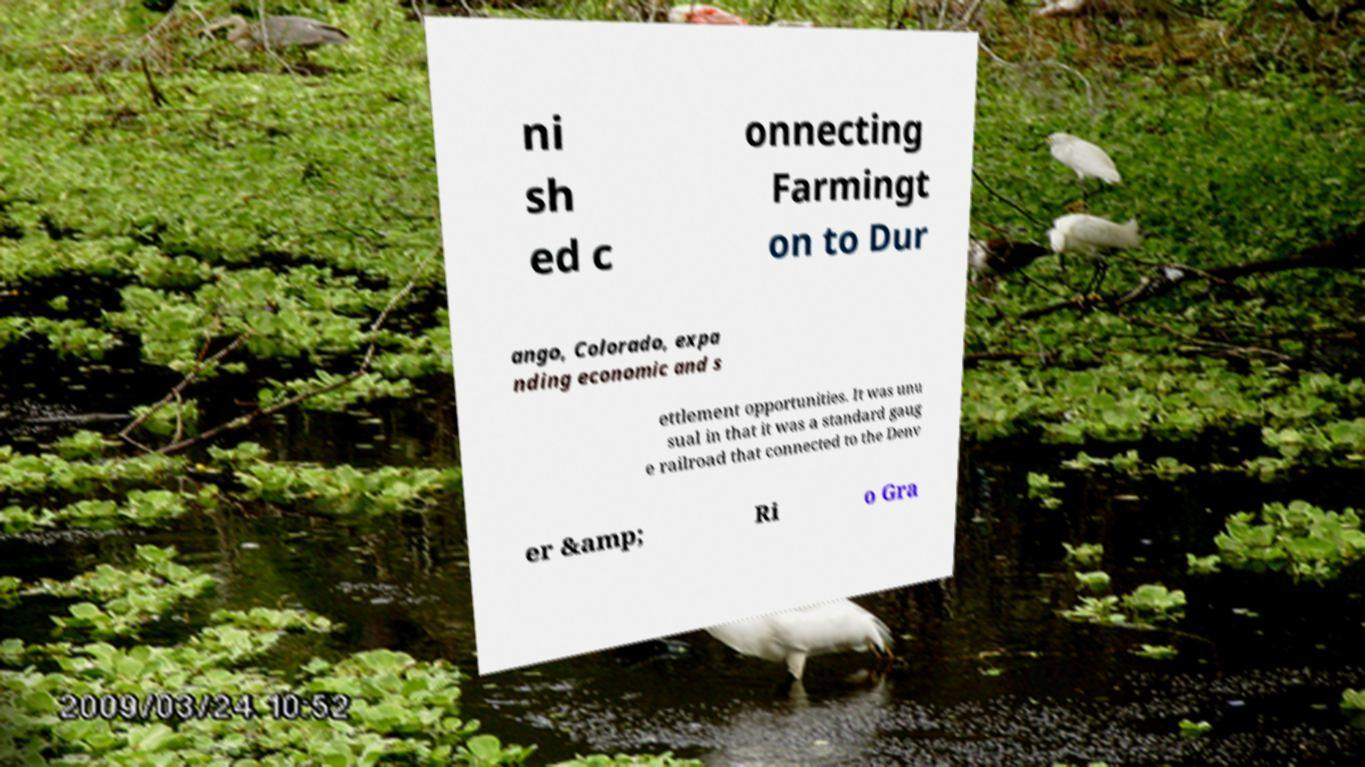What messages or text are displayed in this image? I need them in a readable, typed format. ni sh ed c onnecting Farmingt on to Dur ango, Colorado, expa nding economic and s ettlement opportunities. It was unu sual in that it was a standard gaug e railroad that connected to the Denv er &amp; Ri o Gra 